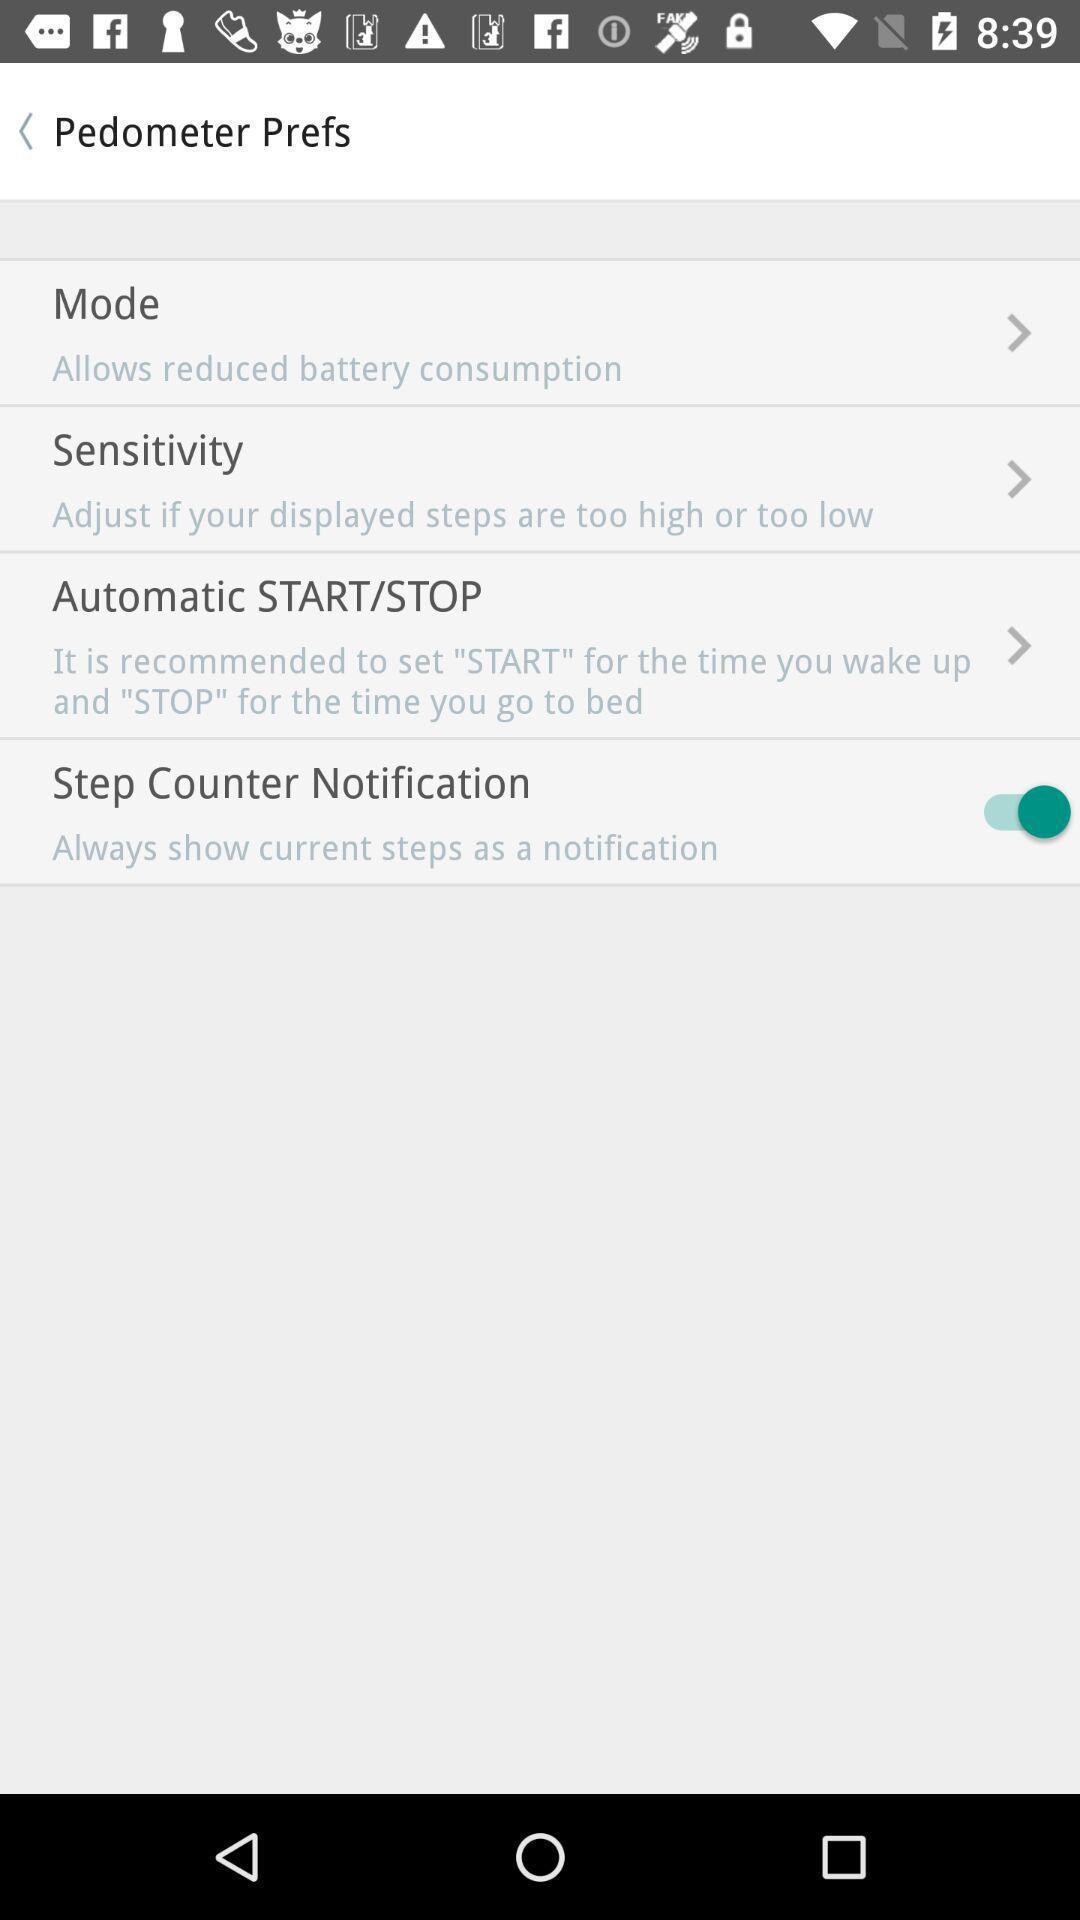Tell me what you see in this picture. Settings page displayed of a fitness app. 